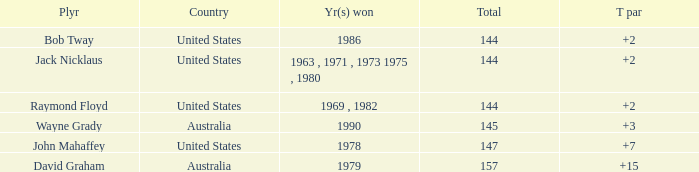What was the average round score of the player who won in 1978? 147.0. 